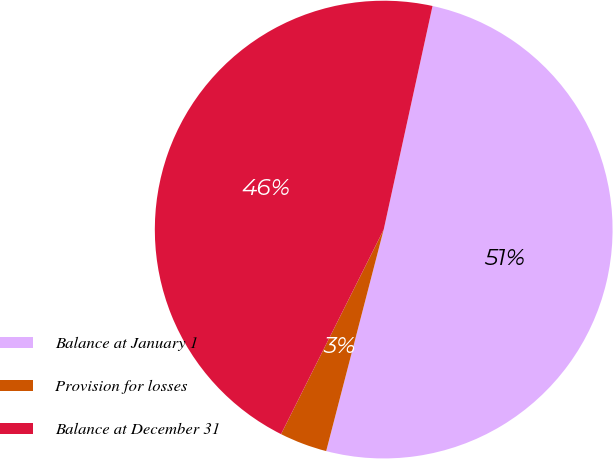Convert chart. <chart><loc_0><loc_0><loc_500><loc_500><pie_chart><fcel>Balance at January 1<fcel>Provision for losses<fcel>Balance at December 31<nl><fcel>50.62%<fcel>3.36%<fcel>46.02%<nl></chart> 